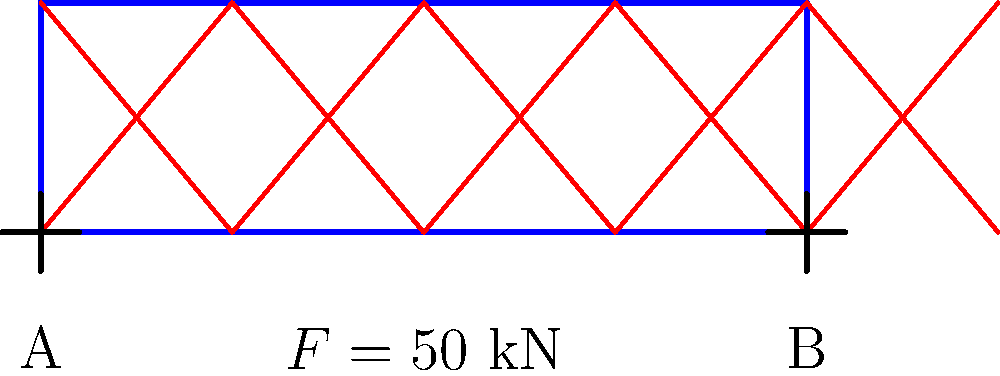As part of your nonprofit organization's initiative to rebuild community structures, you're tasked with designing a simple truss bridge. The bridge span is 10 meters, and it needs to support a maximum load of 50 kN at its center. If the truss depth is 3 meters, determine the maximum force in the top chord members of the truss. Assume the truss behaves as a simply supported beam. To solve this problem, we'll follow these steps:

1) First, we need to calculate the reaction forces at the supports. Since the load is at the center and the bridge is simply supported, each support will bear half of the total load.

   $R_A = R_B = 50 \text{ kN} / 2 = 25 \text{ kN}$

2) Next, we need to calculate the maximum bending moment in the truss. This occurs at the center where the load is applied.

   $M_{max} = R_A \times (L/2) = 25 \text{ kN} \times 5 \text{ m} = 125 \text{ kN}\cdot\text{m}$

3) In a truss, the bending moment is resisted by the top and bottom chords. The force in these chords forms a couple. The magnitude of this force (F) multiplied by the depth of the truss (d) equals the bending moment.

   $F \times d = M_{max}$

4) Rearranging this equation:

   $F = M_{max} / d = 125 \text{ kN}\cdot\text{m} / 3 \text{ m} = 41.67 \text{ kN}$

5) This force of 41.67 kN is the maximum force in the top (and bottom) chord members of the truss.
Answer: 41.67 kN 